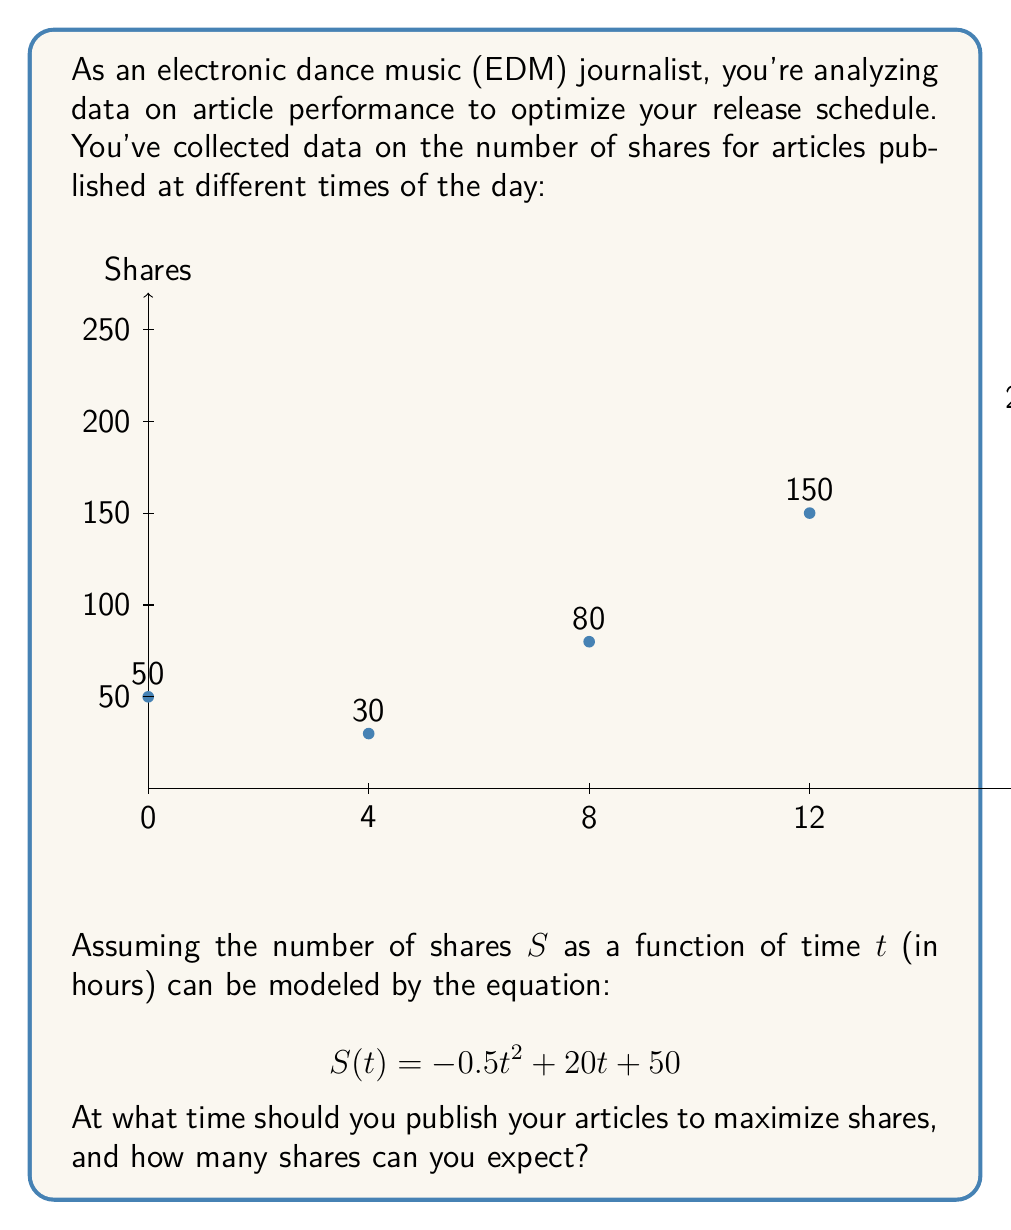Teach me how to tackle this problem. To find the optimal time for publishing articles to maximize shares, we need to find the maximum of the quadratic function $S(t) = -0.5t^2 + 20t + 50$.

Step 1: Find the vertex of the parabola.
For a quadratic function in the form $f(x) = ax^2 + bx + c$, the x-coordinate of the vertex is given by $x = -\frac{b}{2a}$.

In our case, $a = -0.5$, $b = 20$, so:

$t = -\frac{20}{2(-0.5)} = -\frac{20}{-1} = 20$

Step 2: Calculate the maximum number of shares.
Substitute $t = 20$ into the original equation:

$S(20) = -0.5(20)^2 + 20(20) + 50$
$= -0.5(400) + 400 + 50$
$= -200 + 400 + 50$
$= 250$

Therefore, the optimal time to publish articles is 20 hours (or 8 PM), and the expected number of shares at this time is 250.
Answer: 20 hours (8 PM), 250 shares 